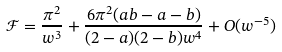Convert formula to latex. <formula><loc_0><loc_0><loc_500><loc_500>\mathcal { F } = \frac { \pi ^ { 2 } } { w ^ { 3 } } + \frac { 6 \pi ^ { 2 } ( a b - a - b ) } { ( 2 - a ) ( 2 - b ) w ^ { 4 } } + O ( w ^ { - 5 } )</formula> 